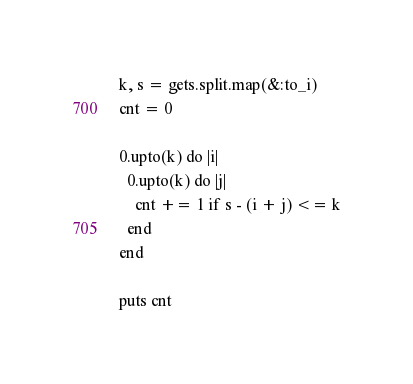Convert code to text. <code><loc_0><loc_0><loc_500><loc_500><_Ruby_>k, s = gets.split.map(&:to_i)
cnt = 0

0.upto(k) do |i|
  0.upto(k) do |j|
    cnt += 1 if s - (i + j) <= k
  end
end

puts cnt
</code> 